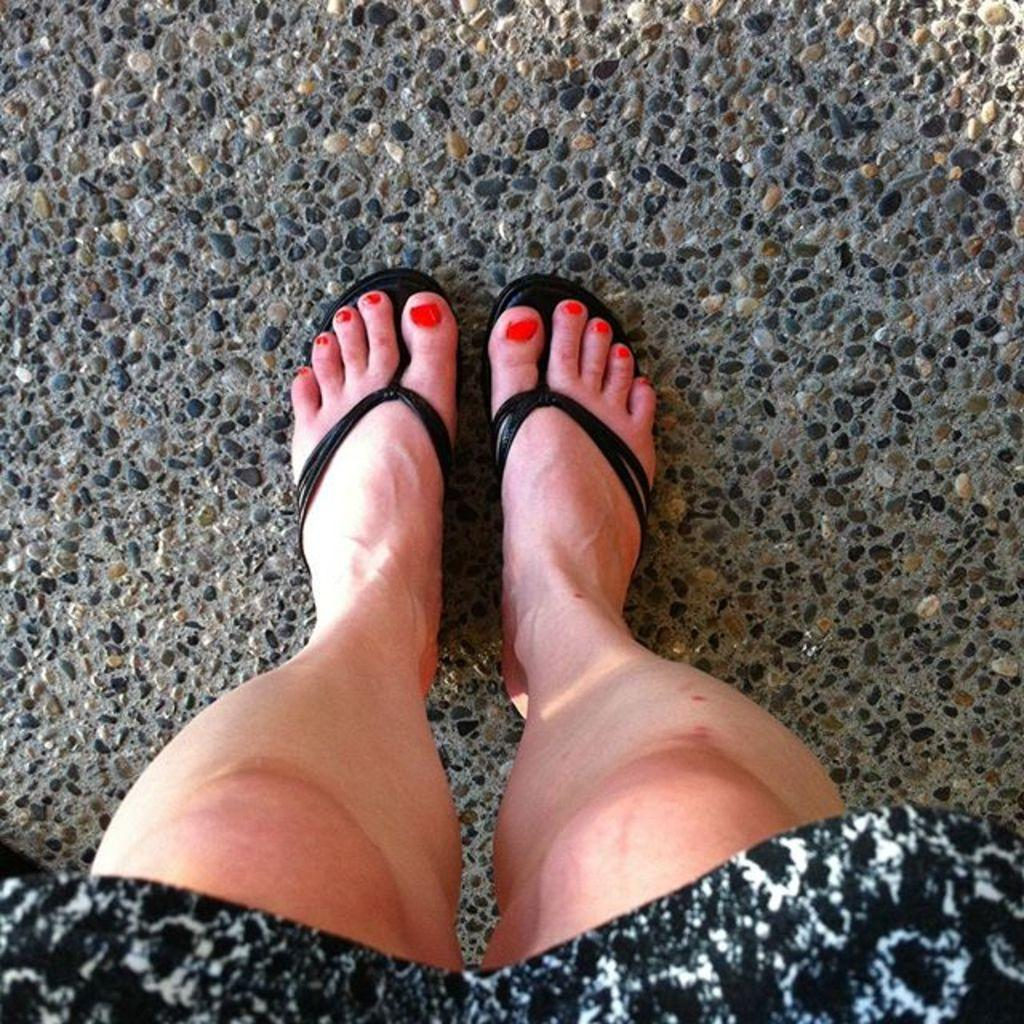What body part can be seen in the image? Human legs are visible in the image. What type of footwear is the person wearing? The person is wearing chappals. What can be seen at the bottom of the image? There is cloth visible at the bottom of the image. How many eggs are being used to make the payment for the chappals in the image? There is no payment or eggs present in the image; it only shows human legs wearing chappals and cloth at the bottom. 